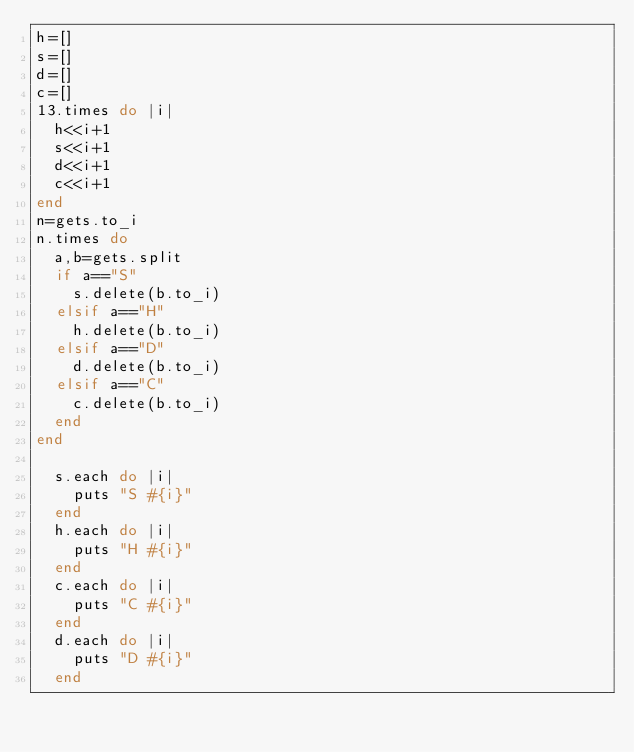<code> <loc_0><loc_0><loc_500><loc_500><_Ruby_>h=[]
s=[]
d=[]
c=[]
13.times do |i|
  h<<i+1
  s<<i+1
  d<<i+1
  c<<i+1
end
n=gets.to_i
n.times do
  a,b=gets.split
  if a=="S"
    s.delete(b.to_i)
  elsif a=="H"
    h.delete(b.to_i)
  elsif a=="D"
    d.delete(b.to_i)
  elsif a=="C"
    c.delete(b.to_i)
  end
end

  s.each do |i|
    puts "S #{i}"
  end
  h.each do |i|
    puts "H #{i}"
  end
  c.each do |i|
    puts "C #{i}"
  end
  d.each do |i|
    puts "D #{i}"
  end
</code> 